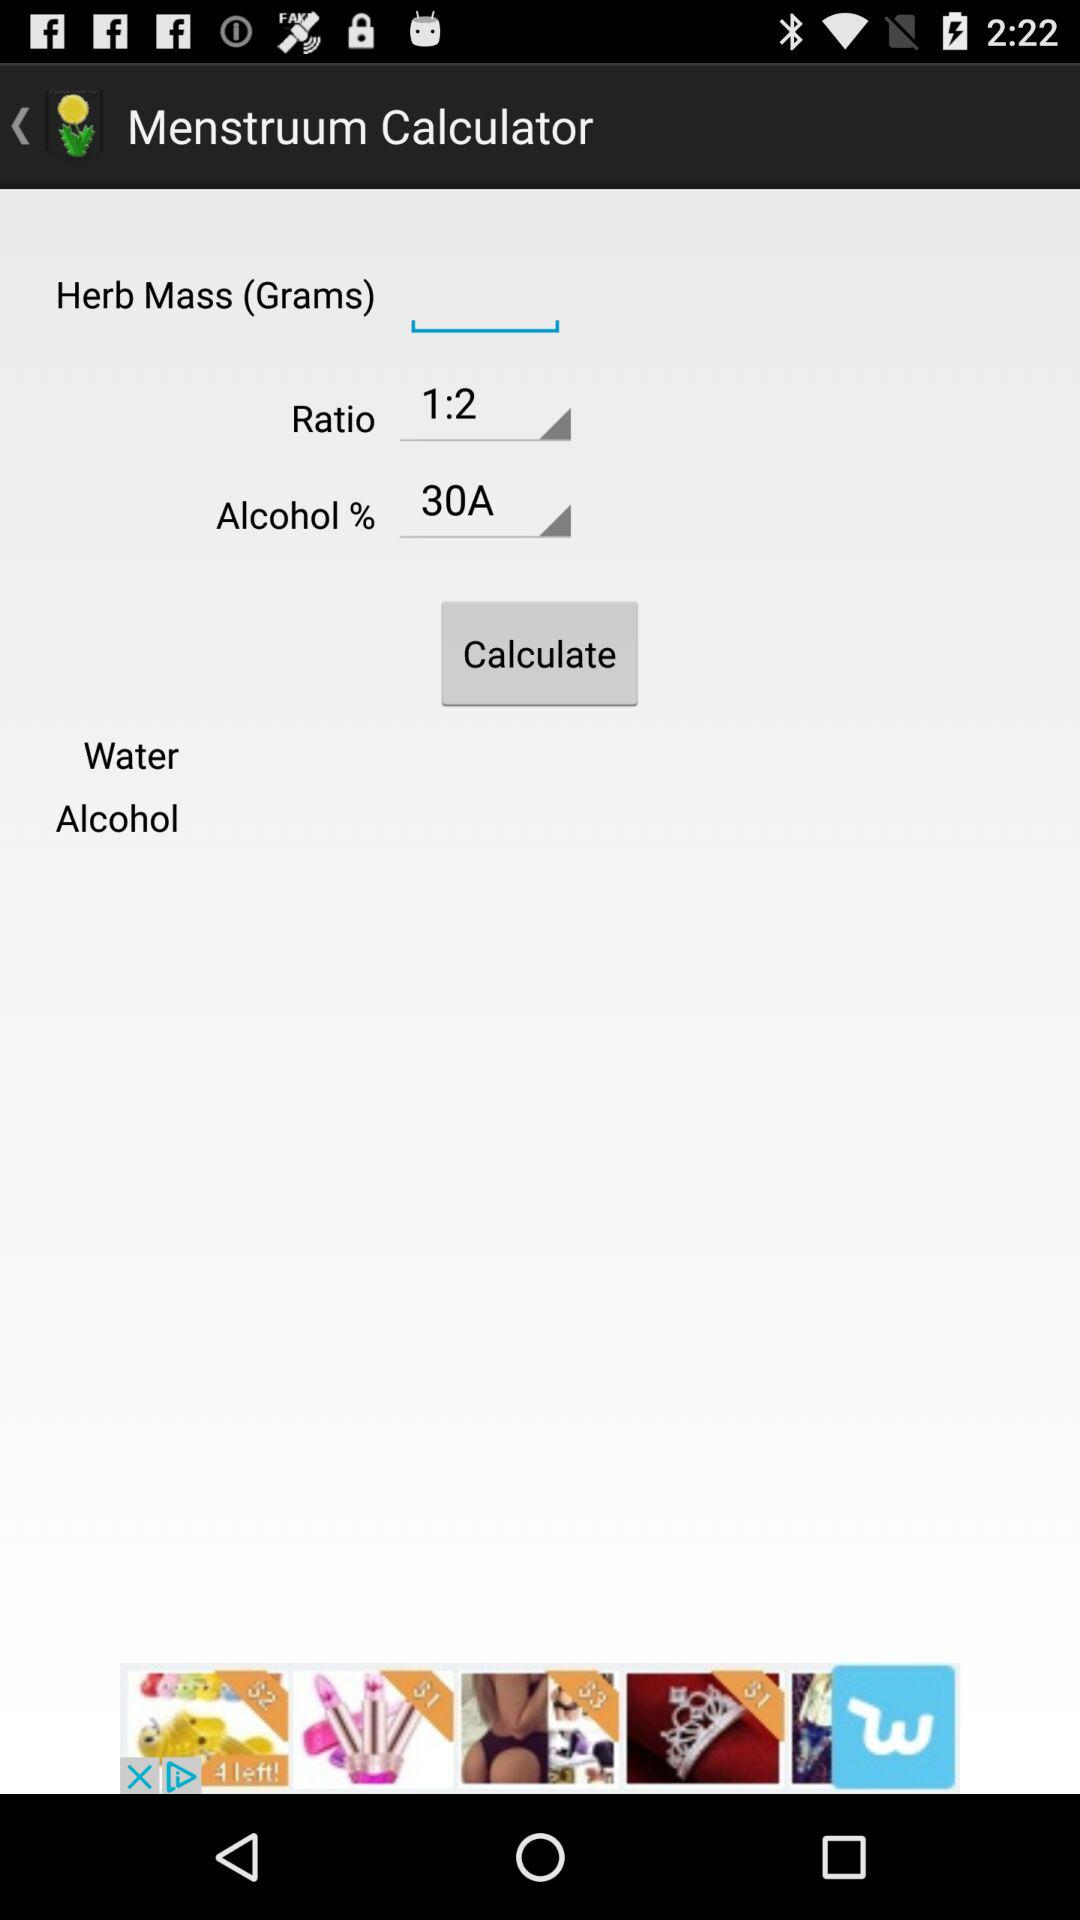What is the selected alcohol percent? The selected alcohol percent is 30 A. 